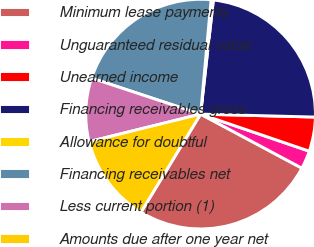<chart> <loc_0><loc_0><loc_500><loc_500><pie_chart><fcel>Minimum lease payments<fcel>Unguaranteed residual value<fcel>Unearned income<fcel>Financing receivables gross<fcel>Allowance for doubtful<fcel>Financing receivables net<fcel>Less current portion (1)<fcel>Amounts due after one year net<nl><fcel>25.89%<fcel>2.57%<fcel>4.82%<fcel>23.64%<fcel>0.32%<fcel>21.38%<fcel>8.93%<fcel>12.46%<nl></chart> 